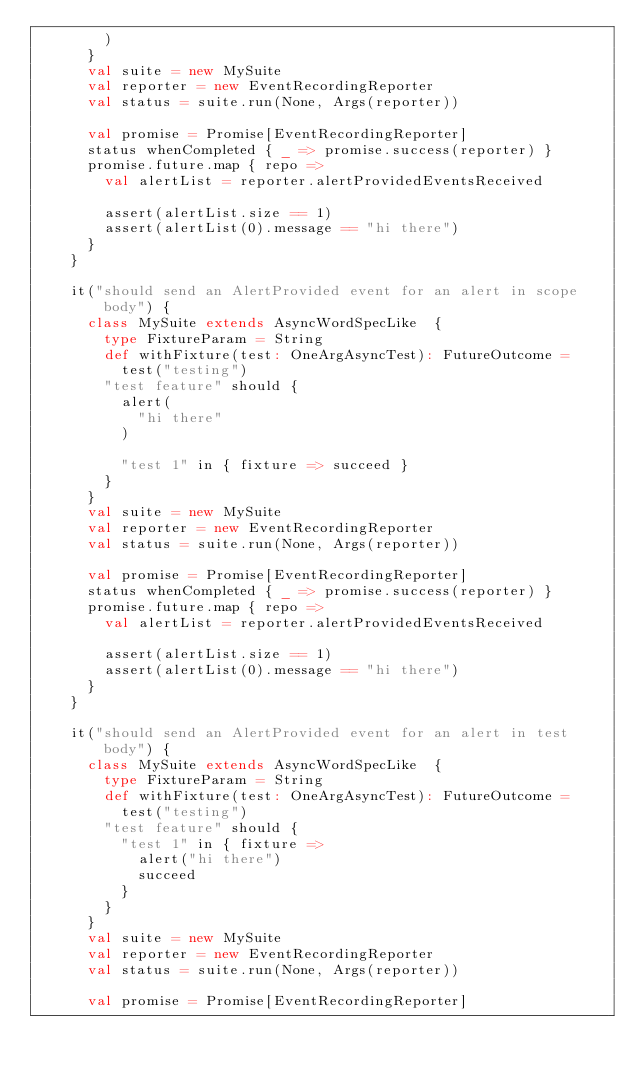<code> <loc_0><loc_0><loc_500><loc_500><_Scala_>        )
      }
      val suite = new MySuite
      val reporter = new EventRecordingReporter
      val status = suite.run(None, Args(reporter))

      val promise = Promise[EventRecordingReporter]
      status whenCompleted { _ => promise.success(reporter) }
      promise.future.map { repo =>
        val alertList = reporter.alertProvidedEventsReceived

        assert(alertList.size == 1)
        assert(alertList(0).message == "hi there")
      }
    }

    it("should send an AlertProvided event for an alert in scope body") {
      class MySuite extends AsyncWordSpecLike  {
        type FixtureParam = String
        def withFixture(test: OneArgAsyncTest): FutureOutcome =
          test("testing")
        "test feature" should {
          alert(
            "hi there"
          )

          "test 1" in { fixture => succeed }
        }
      }
      val suite = new MySuite
      val reporter = new EventRecordingReporter
      val status = suite.run(None, Args(reporter))

      val promise = Promise[EventRecordingReporter]
      status whenCompleted { _ => promise.success(reporter) }
      promise.future.map { repo =>
        val alertList = reporter.alertProvidedEventsReceived

        assert(alertList.size == 1)
        assert(alertList(0).message == "hi there")
      }
    }

    it("should send an AlertProvided event for an alert in test body") {
      class MySuite extends AsyncWordSpecLike  {
        type FixtureParam = String
        def withFixture(test: OneArgAsyncTest): FutureOutcome =
          test("testing")
        "test feature" should {
          "test 1" in { fixture =>
            alert("hi there")
            succeed
          }
        }
      }
      val suite = new MySuite
      val reporter = new EventRecordingReporter
      val status = suite.run(None, Args(reporter))

      val promise = Promise[EventRecordingReporter]</code> 